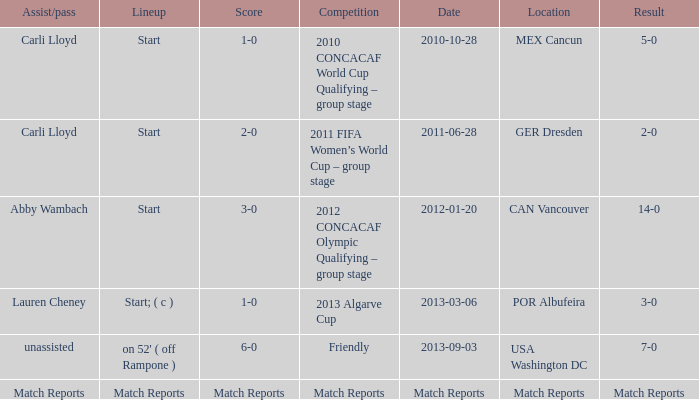Name the Lineup that has an Assist/pass of carli lloyd,a Competition of 2010 concacaf world cup qualifying – group stage? Start. Parse the table in full. {'header': ['Assist/pass', 'Lineup', 'Score', 'Competition', 'Date', 'Location', 'Result'], 'rows': [['Carli Lloyd', 'Start', '1-0', '2010 CONCACAF World Cup Qualifying – group stage', '2010-10-28', 'MEX Cancun', '5-0'], ['Carli Lloyd', 'Start', '2-0', '2011 FIFA Women’s World Cup – group stage', '2011-06-28', 'GER Dresden', '2-0'], ['Abby Wambach', 'Start', '3-0', '2012 CONCACAF Olympic Qualifying – group stage', '2012-01-20', 'CAN Vancouver', '14-0'], ['Lauren Cheney', 'Start; ( c )', '1-0', '2013 Algarve Cup', '2013-03-06', 'POR Albufeira', '3-0'], ['unassisted', "on 52' ( off Rampone )", '6-0', 'Friendly', '2013-09-03', 'USA Washington DC', '7-0'], ['Match Reports', 'Match Reports', 'Match Reports', 'Match Reports', 'Match Reports', 'Match Reports', 'Match Reports']]} 